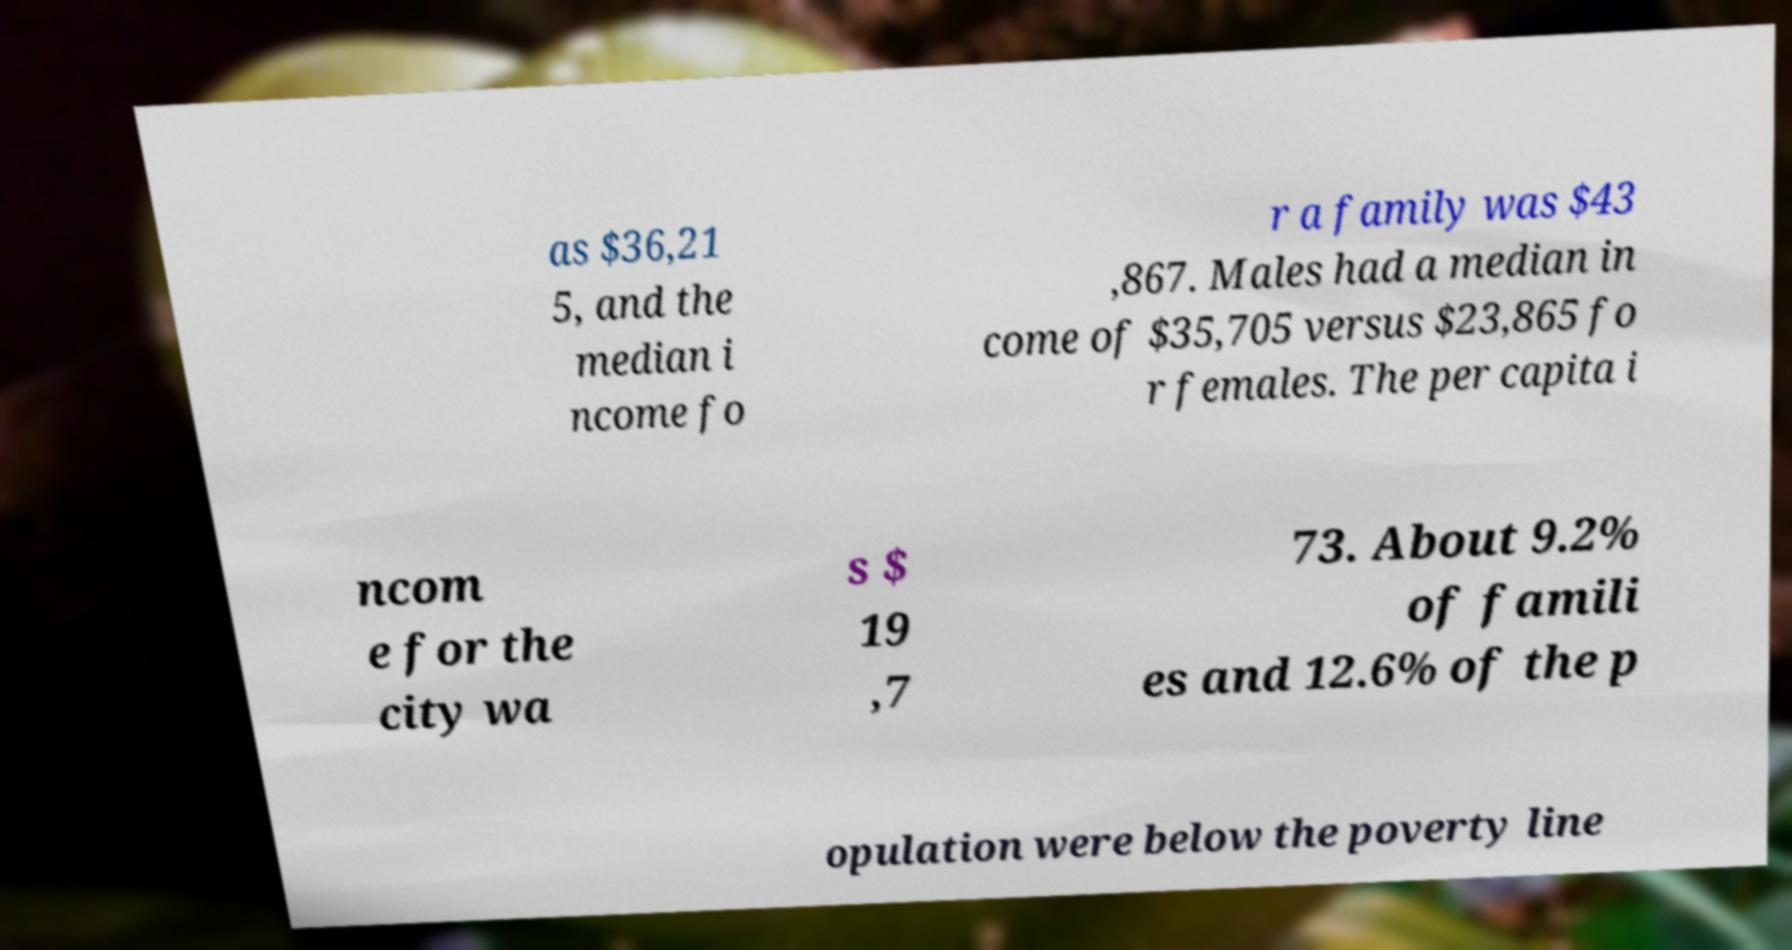Can you accurately transcribe the text from the provided image for me? as $36,21 5, and the median i ncome fo r a family was $43 ,867. Males had a median in come of $35,705 versus $23,865 fo r females. The per capita i ncom e for the city wa s $ 19 ,7 73. About 9.2% of famili es and 12.6% of the p opulation were below the poverty line 